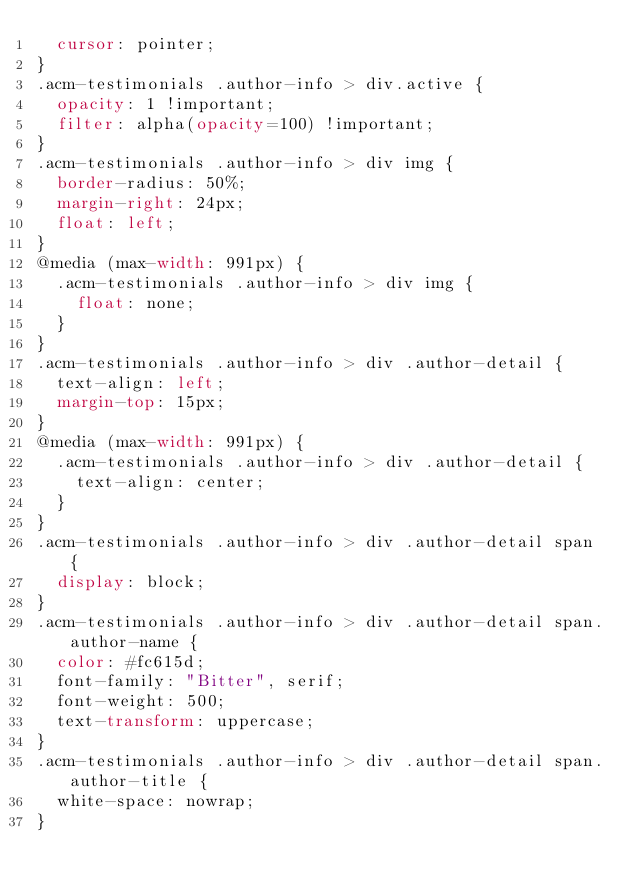<code> <loc_0><loc_0><loc_500><loc_500><_CSS_>  cursor: pointer;
}
.acm-testimonials .author-info > div.active {
  opacity: 1 !important;
  filter: alpha(opacity=100) !important;
}
.acm-testimonials .author-info > div img {
  border-radius: 50%;
  margin-right: 24px;
  float: left;
}
@media (max-width: 991px) {
  .acm-testimonials .author-info > div img {
    float: none;
  }
}
.acm-testimonials .author-info > div .author-detail {
  text-align: left;
  margin-top: 15px;
}
@media (max-width: 991px) {
  .acm-testimonials .author-info > div .author-detail {
    text-align: center;
  }
}
.acm-testimonials .author-info > div .author-detail span {
  display: block;
}
.acm-testimonials .author-info > div .author-detail span.author-name {
  color: #fc615d;
  font-family: "Bitter", serif;
  font-weight: 500;
  text-transform: uppercase;
}
.acm-testimonials .author-info > div .author-detail span.author-title {
  white-space: nowrap;
}</code> 